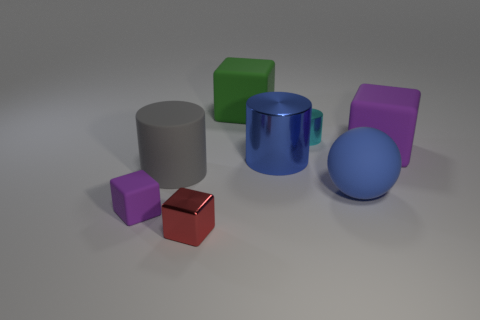Add 2 large blue shiny cylinders. How many objects exist? 10 Subtract all balls. How many objects are left? 7 Add 7 large balls. How many large balls exist? 8 Subtract 0 cyan cubes. How many objects are left? 8 Subtract all blocks. Subtract all big metal objects. How many objects are left? 3 Add 6 purple blocks. How many purple blocks are left? 8 